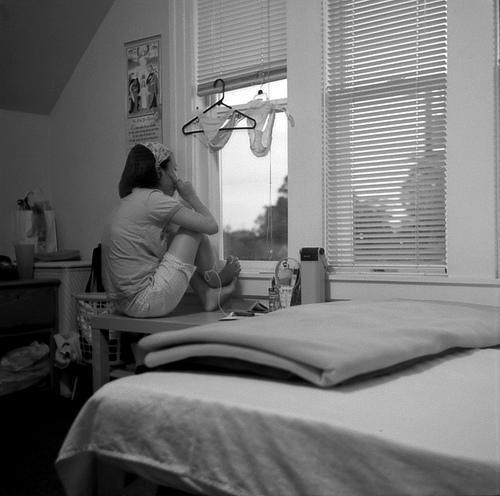Why are the underpants hanging there?
Choose the correct response and explain in the format: 'Answer: answer
Rationale: rationale.'
Options: On display, closet full, to dry, for decoration. Answer: to dry.
Rationale: Underpants hanging there because it have  drying purpose. 